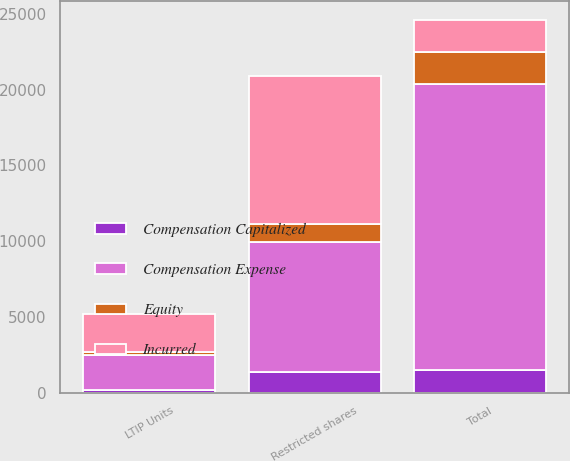Convert chart to OTSL. <chart><loc_0><loc_0><loc_500><loc_500><stacked_bar_chart><ecel><fcel>Restricted shares<fcel>LTIP Units<fcel>Total<nl><fcel>Compensation Expense<fcel>8603<fcel>2334<fcel>18875<nl><fcel>Equity<fcel>1178<fcel>190<fcel>2141<nl><fcel>Incurred<fcel>9781<fcel>2524<fcel>2141<nl><fcel>Compensation Capitalized<fcel>1334<fcel>138<fcel>1472<nl></chart> 